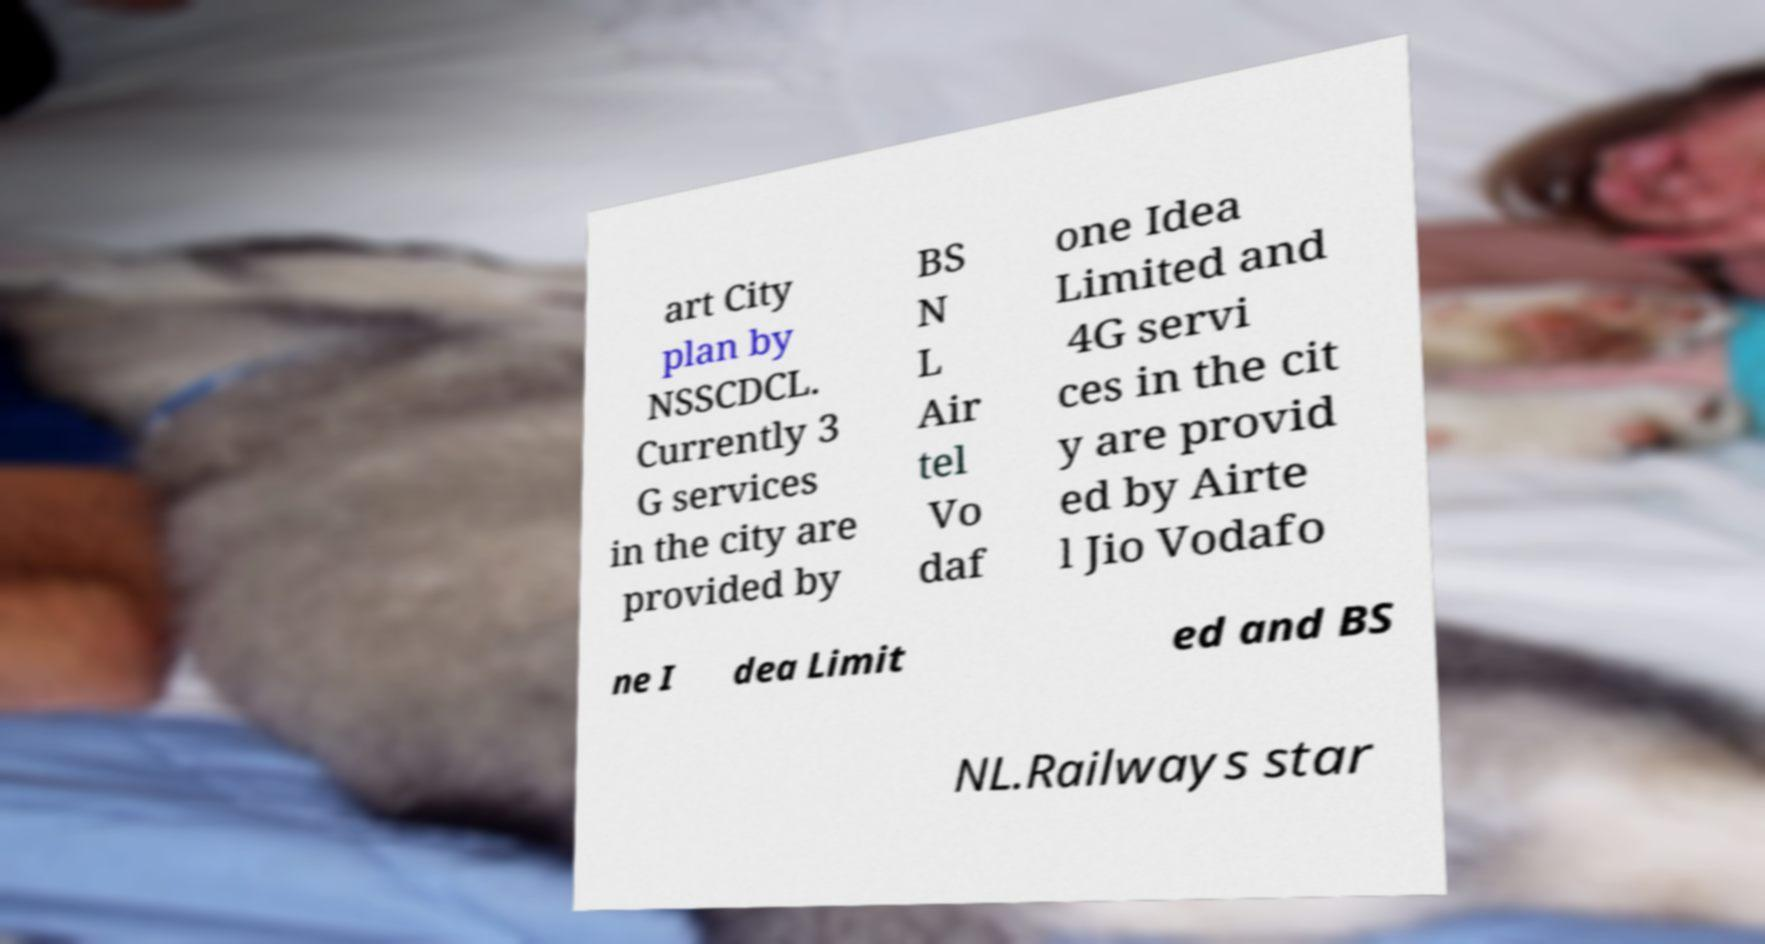Can you read and provide the text displayed in the image?This photo seems to have some interesting text. Can you extract and type it out for me? art City plan by NSSCDCL. Currently 3 G services in the city are provided by BS N L Air tel Vo daf one Idea Limited and 4G servi ces in the cit y are provid ed by Airte l Jio Vodafo ne I dea Limit ed and BS NL.Railways star 